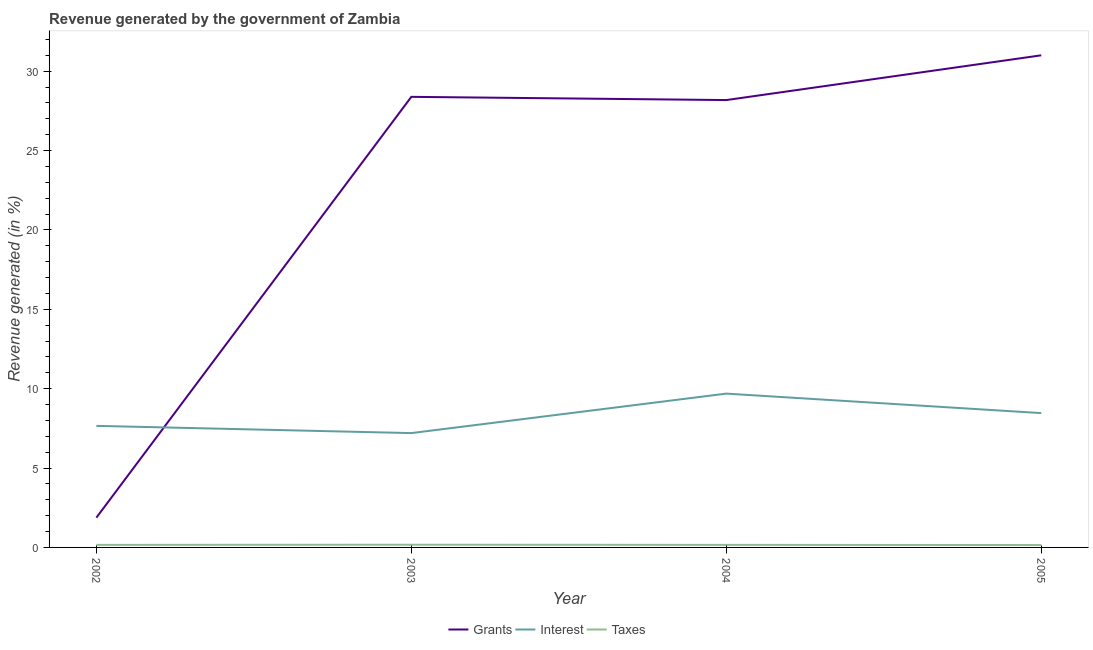How many different coloured lines are there?
Ensure brevity in your answer.  3. What is the percentage of revenue generated by grants in 2004?
Provide a succinct answer. 28.18. Across all years, what is the maximum percentage of revenue generated by interest?
Your answer should be compact. 9.69. Across all years, what is the minimum percentage of revenue generated by grants?
Your response must be concise. 1.88. In which year was the percentage of revenue generated by interest minimum?
Give a very brief answer. 2003. What is the total percentage of revenue generated by taxes in the graph?
Provide a short and direct response. 0.64. What is the difference between the percentage of revenue generated by grants in 2003 and that in 2005?
Your response must be concise. -2.62. What is the difference between the percentage of revenue generated by grants in 2004 and the percentage of revenue generated by taxes in 2003?
Your answer should be very brief. 28.01. What is the average percentage of revenue generated by interest per year?
Offer a terse response. 8.25. In the year 2002, what is the difference between the percentage of revenue generated by taxes and percentage of revenue generated by interest?
Make the answer very short. -7.5. What is the ratio of the percentage of revenue generated by grants in 2004 to that in 2005?
Offer a very short reply. 0.91. Is the difference between the percentage of revenue generated by grants in 2003 and 2005 greater than the difference between the percentage of revenue generated by taxes in 2003 and 2005?
Your answer should be compact. No. What is the difference between the highest and the second highest percentage of revenue generated by interest?
Your response must be concise. 1.23. What is the difference between the highest and the lowest percentage of revenue generated by grants?
Your answer should be compact. 29.12. Is the sum of the percentage of revenue generated by interest in 2002 and 2004 greater than the maximum percentage of revenue generated by taxes across all years?
Keep it short and to the point. Yes. Is it the case that in every year, the sum of the percentage of revenue generated by grants and percentage of revenue generated by interest is greater than the percentage of revenue generated by taxes?
Make the answer very short. Yes. Does the percentage of revenue generated by interest monotonically increase over the years?
Make the answer very short. No. How many lines are there?
Your response must be concise. 3. Are the values on the major ticks of Y-axis written in scientific E-notation?
Ensure brevity in your answer.  No. Does the graph contain grids?
Provide a short and direct response. No. Where does the legend appear in the graph?
Provide a short and direct response. Bottom center. What is the title of the graph?
Give a very brief answer. Revenue generated by the government of Zambia. What is the label or title of the X-axis?
Your answer should be very brief. Year. What is the label or title of the Y-axis?
Give a very brief answer. Revenue generated (in %). What is the Revenue generated (in %) of Grants in 2002?
Make the answer very short. 1.88. What is the Revenue generated (in %) in Interest in 2002?
Your answer should be compact. 7.66. What is the Revenue generated (in %) of Taxes in 2002?
Your response must be concise. 0.16. What is the Revenue generated (in %) of Grants in 2003?
Make the answer very short. 28.38. What is the Revenue generated (in %) in Interest in 2003?
Provide a short and direct response. 7.2. What is the Revenue generated (in %) of Taxes in 2003?
Make the answer very short. 0.17. What is the Revenue generated (in %) of Grants in 2004?
Your answer should be very brief. 28.18. What is the Revenue generated (in %) in Interest in 2004?
Provide a succinct answer. 9.69. What is the Revenue generated (in %) in Taxes in 2004?
Keep it short and to the point. 0.16. What is the Revenue generated (in %) of Grants in 2005?
Your answer should be very brief. 31. What is the Revenue generated (in %) in Interest in 2005?
Ensure brevity in your answer.  8.46. What is the Revenue generated (in %) of Taxes in 2005?
Your answer should be very brief. 0.15. Across all years, what is the maximum Revenue generated (in %) in Grants?
Make the answer very short. 31. Across all years, what is the maximum Revenue generated (in %) of Interest?
Your response must be concise. 9.69. Across all years, what is the maximum Revenue generated (in %) in Taxes?
Provide a succinct answer. 0.17. Across all years, what is the minimum Revenue generated (in %) of Grants?
Offer a very short reply. 1.88. Across all years, what is the minimum Revenue generated (in %) of Interest?
Your answer should be compact. 7.2. Across all years, what is the minimum Revenue generated (in %) of Taxes?
Your answer should be very brief. 0.15. What is the total Revenue generated (in %) in Grants in the graph?
Ensure brevity in your answer.  89.44. What is the total Revenue generated (in %) of Interest in the graph?
Your response must be concise. 33.01. What is the total Revenue generated (in %) in Taxes in the graph?
Give a very brief answer. 0.64. What is the difference between the Revenue generated (in %) of Grants in 2002 and that in 2003?
Ensure brevity in your answer.  -26.51. What is the difference between the Revenue generated (in %) in Interest in 2002 and that in 2003?
Your answer should be compact. 0.46. What is the difference between the Revenue generated (in %) in Taxes in 2002 and that in 2003?
Ensure brevity in your answer.  -0.01. What is the difference between the Revenue generated (in %) in Grants in 2002 and that in 2004?
Give a very brief answer. -26.3. What is the difference between the Revenue generated (in %) in Interest in 2002 and that in 2004?
Provide a succinct answer. -2.03. What is the difference between the Revenue generated (in %) in Taxes in 2002 and that in 2004?
Your answer should be compact. -0. What is the difference between the Revenue generated (in %) of Grants in 2002 and that in 2005?
Your answer should be very brief. -29.12. What is the difference between the Revenue generated (in %) of Interest in 2002 and that in 2005?
Your answer should be compact. -0.8. What is the difference between the Revenue generated (in %) of Taxes in 2002 and that in 2005?
Offer a terse response. 0.01. What is the difference between the Revenue generated (in %) in Grants in 2003 and that in 2004?
Offer a terse response. 0.2. What is the difference between the Revenue generated (in %) of Interest in 2003 and that in 2004?
Provide a short and direct response. -2.49. What is the difference between the Revenue generated (in %) in Taxes in 2003 and that in 2004?
Your response must be concise. 0.01. What is the difference between the Revenue generated (in %) in Grants in 2003 and that in 2005?
Ensure brevity in your answer.  -2.62. What is the difference between the Revenue generated (in %) of Interest in 2003 and that in 2005?
Your answer should be compact. -1.26. What is the difference between the Revenue generated (in %) of Taxes in 2003 and that in 2005?
Provide a succinct answer. 0.02. What is the difference between the Revenue generated (in %) of Grants in 2004 and that in 2005?
Offer a very short reply. -2.82. What is the difference between the Revenue generated (in %) in Interest in 2004 and that in 2005?
Keep it short and to the point. 1.23. What is the difference between the Revenue generated (in %) in Taxes in 2004 and that in 2005?
Offer a very short reply. 0.01. What is the difference between the Revenue generated (in %) of Grants in 2002 and the Revenue generated (in %) of Interest in 2003?
Your answer should be compact. -5.33. What is the difference between the Revenue generated (in %) of Grants in 2002 and the Revenue generated (in %) of Taxes in 2003?
Provide a succinct answer. 1.71. What is the difference between the Revenue generated (in %) of Interest in 2002 and the Revenue generated (in %) of Taxes in 2003?
Provide a succinct answer. 7.49. What is the difference between the Revenue generated (in %) of Grants in 2002 and the Revenue generated (in %) of Interest in 2004?
Make the answer very short. -7.81. What is the difference between the Revenue generated (in %) in Grants in 2002 and the Revenue generated (in %) in Taxes in 2004?
Ensure brevity in your answer.  1.71. What is the difference between the Revenue generated (in %) in Interest in 2002 and the Revenue generated (in %) in Taxes in 2004?
Your answer should be very brief. 7.5. What is the difference between the Revenue generated (in %) in Grants in 2002 and the Revenue generated (in %) in Interest in 2005?
Ensure brevity in your answer.  -6.59. What is the difference between the Revenue generated (in %) of Grants in 2002 and the Revenue generated (in %) of Taxes in 2005?
Your response must be concise. 1.72. What is the difference between the Revenue generated (in %) in Interest in 2002 and the Revenue generated (in %) in Taxes in 2005?
Provide a succinct answer. 7.51. What is the difference between the Revenue generated (in %) of Grants in 2003 and the Revenue generated (in %) of Interest in 2004?
Give a very brief answer. 18.69. What is the difference between the Revenue generated (in %) of Grants in 2003 and the Revenue generated (in %) of Taxes in 2004?
Make the answer very short. 28.22. What is the difference between the Revenue generated (in %) of Interest in 2003 and the Revenue generated (in %) of Taxes in 2004?
Make the answer very short. 7.04. What is the difference between the Revenue generated (in %) of Grants in 2003 and the Revenue generated (in %) of Interest in 2005?
Keep it short and to the point. 19.92. What is the difference between the Revenue generated (in %) in Grants in 2003 and the Revenue generated (in %) in Taxes in 2005?
Make the answer very short. 28.23. What is the difference between the Revenue generated (in %) in Interest in 2003 and the Revenue generated (in %) in Taxes in 2005?
Your answer should be very brief. 7.05. What is the difference between the Revenue generated (in %) of Grants in 2004 and the Revenue generated (in %) of Interest in 2005?
Your answer should be very brief. 19.72. What is the difference between the Revenue generated (in %) in Grants in 2004 and the Revenue generated (in %) in Taxes in 2005?
Your answer should be compact. 28.03. What is the difference between the Revenue generated (in %) of Interest in 2004 and the Revenue generated (in %) of Taxes in 2005?
Offer a very short reply. 9.54. What is the average Revenue generated (in %) of Grants per year?
Your response must be concise. 22.36. What is the average Revenue generated (in %) in Interest per year?
Give a very brief answer. 8.25. What is the average Revenue generated (in %) in Taxes per year?
Provide a short and direct response. 0.16. In the year 2002, what is the difference between the Revenue generated (in %) of Grants and Revenue generated (in %) of Interest?
Give a very brief answer. -5.78. In the year 2002, what is the difference between the Revenue generated (in %) in Grants and Revenue generated (in %) in Taxes?
Offer a very short reply. 1.72. In the year 2002, what is the difference between the Revenue generated (in %) in Interest and Revenue generated (in %) in Taxes?
Ensure brevity in your answer.  7.5. In the year 2003, what is the difference between the Revenue generated (in %) in Grants and Revenue generated (in %) in Interest?
Your response must be concise. 21.18. In the year 2003, what is the difference between the Revenue generated (in %) of Grants and Revenue generated (in %) of Taxes?
Ensure brevity in your answer.  28.21. In the year 2003, what is the difference between the Revenue generated (in %) of Interest and Revenue generated (in %) of Taxes?
Provide a succinct answer. 7.03. In the year 2004, what is the difference between the Revenue generated (in %) of Grants and Revenue generated (in %) of Interest?
Your response must be concise. 18.49. In the year 2004, what is the difference between the Revenue generated (in %) of Grants and Revenue generated (in %) of Taxes?
Keep it short and to the point. 28.02. In the year 2004, what is the difference between the Revenue generated (in %) of Interest and Revenue generated (in %) of Taxes?
Keep it short and to the point. 9.53. In the year 2005, what is the difference between the Revenue generated (in %) of Grants and Revenue generated (in %) of Interest?
Offer a terse response. 22.54. In the year 2005, what is the difference between the Revenue generated (in %) of Grants and Revenue generated (in %) of Taxes?
Your answer should be compact. 30.85. In the year 2005, what is the difference between the Revenue generated (in %) in Interest and Revenue generated (in %) in Taxes?
Your response must be concise. 8.31. What is the ratio of the Revenue generated (in %) of Grants in 2002 to that in 2003?
Make the answer very short. 0.07. What is the ratio of the Revenue generated (in %) of Interest in 2002 to that in 2003?
Provide a succinct answer. 1.06. What is the ratio of the Revenue generated (in %) of Taxes in 2002 to that in 2003?
Make the answer very short. 0.95. What is the ratio of the Revenue generated (in %) in Grants in 2002 to that in 2004?
Make the answer very short. 0.07. What is the ratio of the Revenue generated (in %) in Interest in 2002 to that in 2004?
Make the answer very short. 0.79. What is the ratio of the Revenue generated (in %) of Grants in 2002 to that in 2005?
Offer a very short reply. 0.06. What is the ratio of the Revenue generated (in %) in Interest in 2002 to that in 2005?
Offer a terse response. 0.91. What is the ratio of the Revenue generated (in %) in Taxes in 2002 to that in 2005?
Provide a short and direct response. 1.06. What is the ratio of the Revenue generated (in %) of Grants in 2003 to that in 2004?
Provide a succinct answer. 1.01. What is the ratio of the Revenue generated (in %) in Interest in 2003 to that in 2004?
Offer a terse response. 0.74. What is the ratio of the Revenue generated (in %) in Taxes in 2003 to that in 2004?
Keep it short and to the point. 1.05. What is the ratio of the Revenue generated (in %) of Grants in 2003 to that in 2005?
Give a very brief answer. 0.92. What is the ratio of the Revenue generated (in %) of Interest in 2003 to that in 2005?
Keep it short and to the point. 0.85. What is the ratio of the Revenue generated (in %) in Taxes in 2003 to that in 2005?
Your answer should be compact. 1.12. What is the ratio of the Revenue generated (in %) of Grants in 2004 to that in 2005?
Provide a succinct answer. 0.91. What is the ratio of the Revenue generated (in %) of Interest in 2004 to that in 2005?
Offer a very short reply. 1.15. What is the ratio of the Revenue generated (in %) in Taxes in 2004 to that in 2005?
Provide a succinct answer. 1.07. What is the difference between the highest and the second highest Revenue generated (in %) in Grants?
Make the answer very short. 2.62. What is the difference between the highest and the second highest Revenue generated (in %) in Interest?
Offer a terse response. 1.23. What is the difference between the highest and the second highest Revenue generated (in %) in Taxes?
Your answer should be very brief. 0.01. What is the difference between the highest and the lowest Revenue generated (in %) of Grants?
Provide a short and direct response. 29.12. What is the difference between the highest and the lowest Revenue generated (in %) in Interest?
Ensure brevity in your answer.  2.49. What is the difference between the highest and the lowest Revenue generated (in %) of Taxes?
Give a very brief answer. 0.02. 